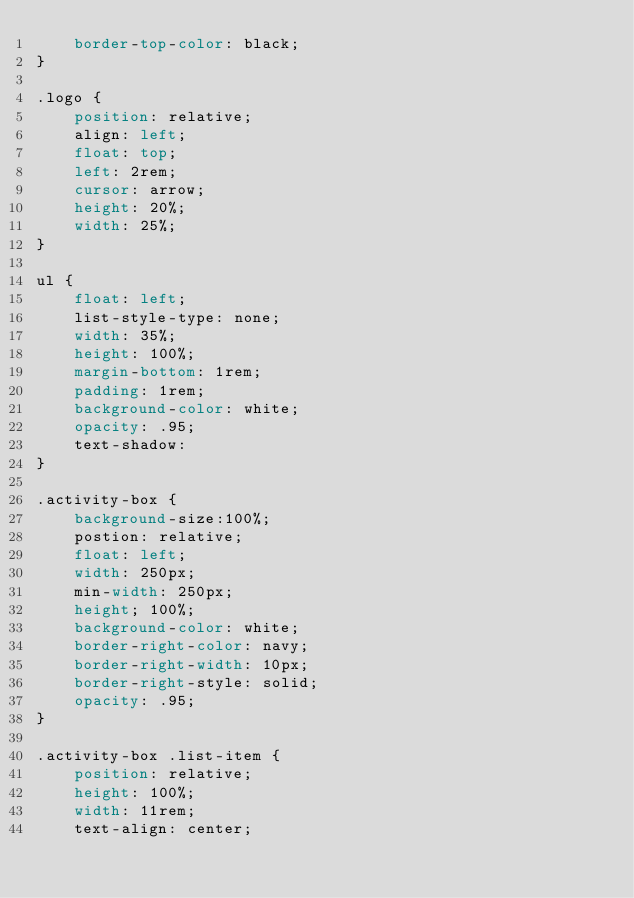Convert code to text. <code><loc_0><loc_0><loc_500><loc_500><_CSS_>    border-top-color: black;
}

.logo {
    position: relative;
    align: left;
    float: top;
    left: 2rem;
    cursor: arrow;
    height: 20%;
    width: 25%;
}

ul {
    float: left;
    list-style-type: none;
    width: 35%;
    height: 100%;
    margin-bottom: 1rem;
    padding: 1rem;
    background-color: white;
    opacity: .95;
    text-shadow: 
}

.activity-box {
    background-size:100%;
    postion: relative;
    float: left;
    width: 250px;
    min-width: 250px;
    height; 100%;
    background-color: white;
    border-right-color: navy;
    border-right-width: 10px;
    border-right-style: solid;
    opacity: .95;
}

.activity-box .list-item {
    position: relative;
    height: 100%;
    width: 11rem;
    text-align: center;</code> 